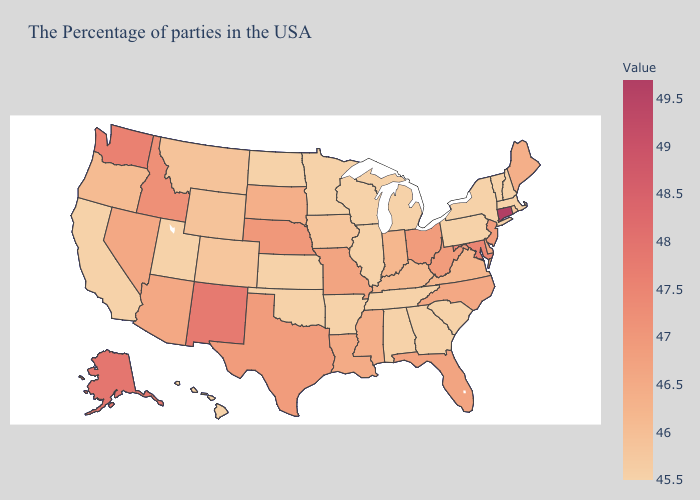Does Alabama have a higher value than Mississippi?
Short answer required. No. Which states have the lowest value in the USA?
Concise answer only. Massachusetts, New Hampshire, Vermont, New York, Pennsylvania, South Carolina, Georgia, Michigan, Alabama, Tennessee, Wisconsin, Illinois, Arkansas, Minnesota, Kansas, Oklahoma, North Dakota, Utah, California, Hawaii. Does the map have missing data?
Answer briefly. No. Is the legend a continuous bar?
Keep it brief. Yes. Which states hav the highest value in the MidWest?
Give a very brief answer. Nebraska. 